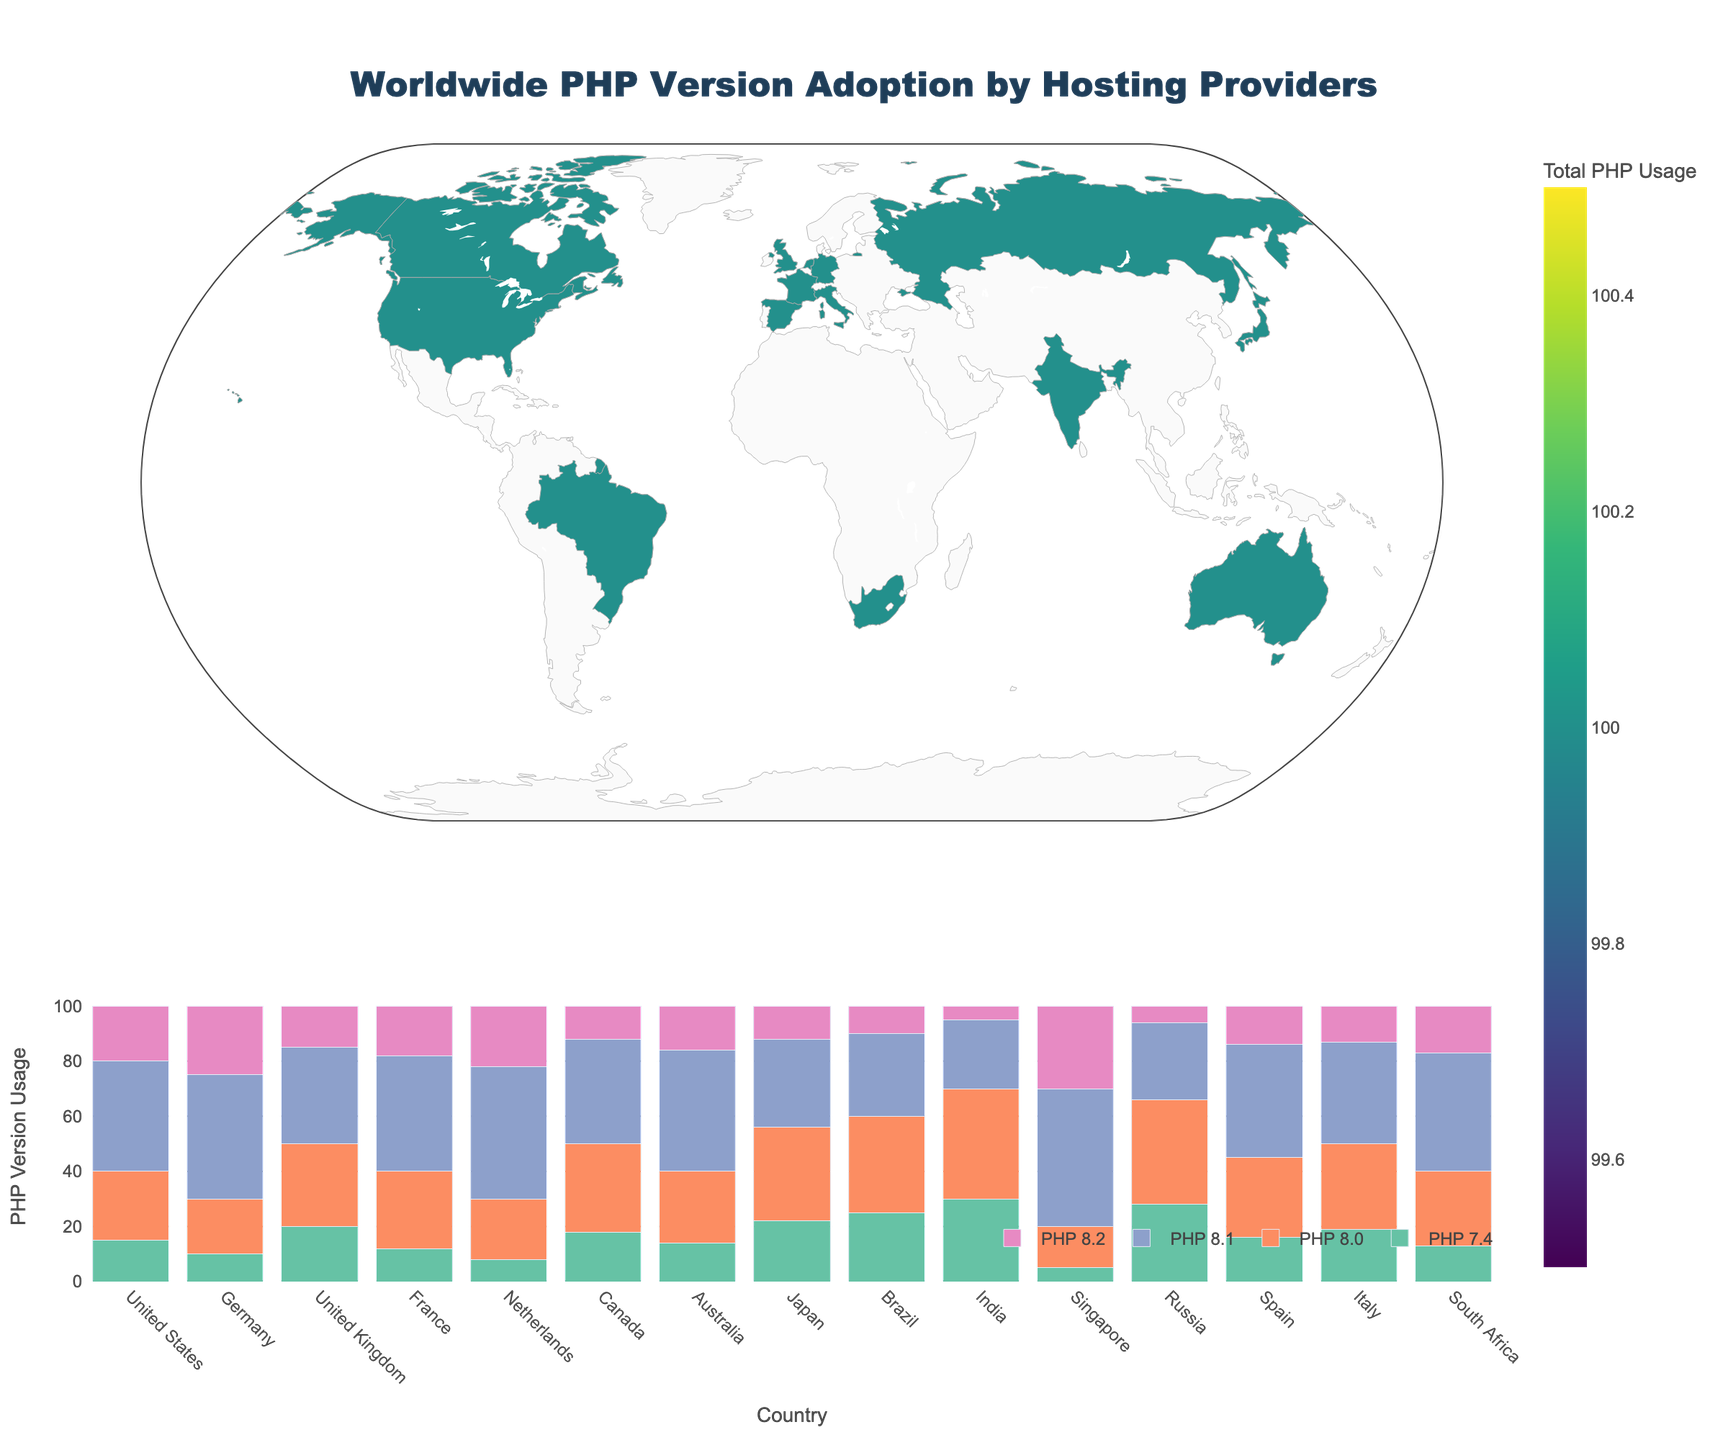What is the title of the figure? The title is often prominently displayed and typically uses a larger font size at the top center of the plot. In this figure, the title is 'Worldwide PHP Version Adoption by Hosting Providers', clearly indicating the subject matter.
Answer: Worldwide PHP Version Adoption by Hosting Providers What is the color scale used for the choropleth map? The color scale is used to represent the data values visually in the map. In this figure, the colors range from lighter to darker shades of the 'Viridis' color scale, which helps to distinguish varying levels of PHP adoption.
Answer: Viridis Which country has the highest total PHP version usage? To find the country with the highest total usage, look at the values in the choropleth color density, and identify which country is the darkest. The country with the highest total PHP usage based on the provided dataset is India.
Answer: India How does the PHP 8.1 adoption rate in Japan compare with that in Russia? In the bar chart, locate the bars for PHP 8.1 for Japan and Russia, which are differentiated by color and hover texts. Japan's PHP 8.1 adoption rate is 32%, while Russia's is 28%.
Answer: Japan is higher Which PHP version has the highest adoption rate in DigitalOcean, Singapore? In the bar chart's x-axis, find Singapore and compare the heights of the bars for each PHP version. You will see the bar for PHP 8.1 is the tallest, indicating it has the highest adoption rate.
Answer: PHP 8.1 How does the average PHP 7.4 adoption rate compare between countries in Europe? (Germany, United Kingdom, France, Netherlands, Italy, Spain) First, sum the PHP 7.4 adoption rates for the specified countries and divide by the number of countries. (10 + 20 + 12 + 8 + 19 + 16) / 6 = 85 / 6 = 14.1667. This calculation shows the average rate among these European countries.
Answer: 14.17 Which hosting provider has the lowest adoption rate for PHP 8.2? By reviewing the bars representing PHP 8.2 adoption rates across all countries, you can identify the shortest bar's hover text. The provider with the lowest rate is HostIndia in India with 5%.
Answer: HostIndia What can you infer about the preference for PHP versions in India based on the plot? Observing the bars for India, PHP 8.0 has the highest adoption rate, while PHP 8.2 has the lowest. This indicates a strong preference for PHP 8.0 over other versions.
Answer: Preference for PHP 8.0 Which countries have an equal total PHP usage? On the choropleth map, if two countries have similar shades or hover texts indicating the same total, they have equal usage. By checking the values in the provided dataset, no countries have exactly equal totals, so none have equal PHP usage.
Answer: None 